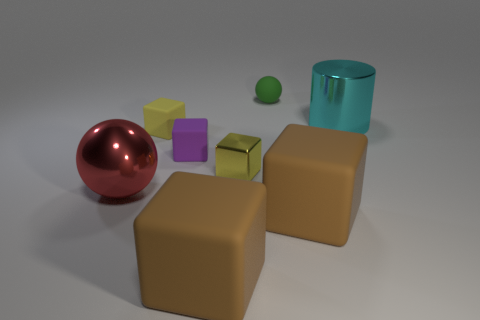There is a matte thing that is to the left of the purple block; is its size the same as the ball that is in front of the small shiny object?
Your answer should be compact. No. What number of cubes are either tiny green matte objects or matte things?
Ensure brevity in your answer.  4. Are there any small purple cubes?
Give a very brief answer. Yes. Is there anything else that has the same shape as the green thing?
Your answer should be compact. Yes. Is the color of the large shiny cylinder the same as the small matte sphere?
Offer a terse response. No. How many objects are either shiny things left of the shiny cylinder or big cyan things?
Give a very brief answer. 3. There is a small object right of the yellow thing in front of the small purple rubber object; what number of small rubber cubes are behind it?
Make the answer very short. 0. Are there any other things that have the same size as the red object?
Your response must be concise. Yes. There is a big brown thing that is to the right of the sphere right of the ball that is in front of the cyan metallic cylinder; what is its shape?
Make the answer very short. Cube. What number of other things are there of the same color as the big metal ball?
Your answer should be very brief. 0. 